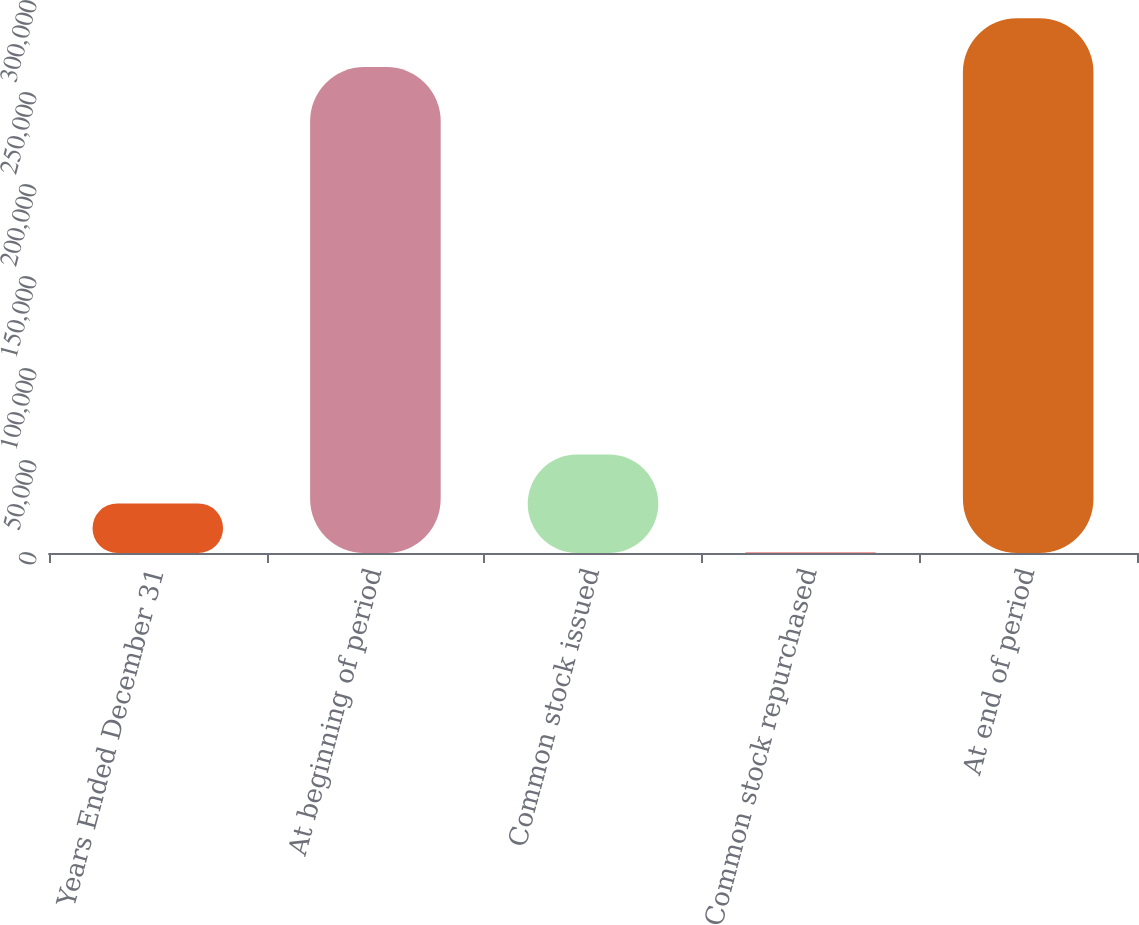Convert chart. <chart><loc_0><loc_0><loc_500><loc_500><bar_chart><fcel>Years Ended December 31<fcel>At beginning of period<fcel>Common stock issued<fcel>Common stock repurchased<fcel>At end of period<nl><fcel>26934.1<fcel>264072<fcel>53512.2<fcel>356<fcel>290650<nl></chart> 